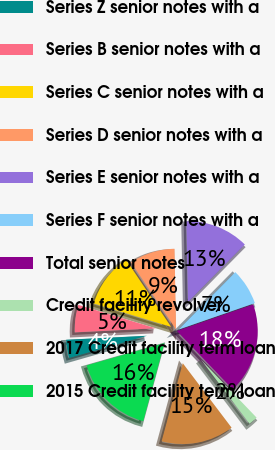Convert chart to OTSL. <chart><loc_0><loc_0><loc_500><loc_500><pie_chart><fcel>Series Z senior notes with a<fcel>Series B senior notes with a<fcel>Series C senior notes with a<fcel>Series D senior notes with a<fcel>Series E senior notes with a<fcel>Series F senior notes with a<fcel>Total senior notes<fcel>Credit facility revolver<fcel>2017 Credit facility term loan<fcel>2015 Credit facility term loan<nl><fcel>3.65%<fcel>5.47%<fcel>10.91%<fcel>9.09%<fcel>12.72%<fcel>7.28%<fcel>18.16%<fcel>1.84%<fcel>14.53%<fcel>16.35%<nl></chart> 